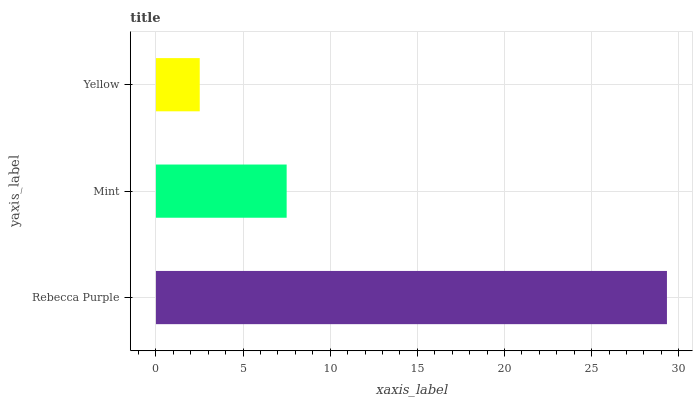Is Yellow the minimum?
Answer yes or no. Yes. Is Rebecca Purple the maximum?
Answer yes or no. Yes. Is Mint the minimum?
Answer yes or no. No. Is Mint the maximum?
Answer yes or no. No. Is Rebecca Purple greater than Mint?
Answer yes or no. Yes. Is Mint less than Rebecca Purple?
Answer yes or no. Yes. Is Mint greater than Rebecca Purple?
Answer yes or no. No. Is Rebecca Purple less than Mint?
Answer yes or no. No. Is Mint the high median?
Answer yes or no. Yes. Is Mint the low median?
Answer yes or no. Yes. Is Rebecca Purple the high median?
Answer yes or no. No. Is Rebecca Purple the low median?
Answer yes or no. No. 